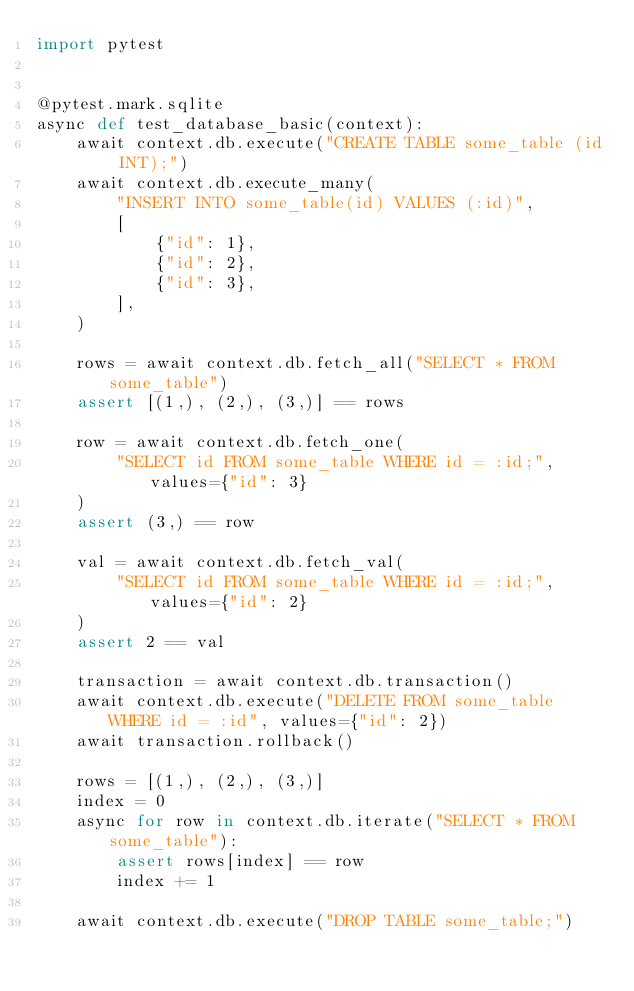<code> <loc_0><loc_0><loc_500><loc_500><_Python_>import pytest


@pytest.mark.sqlite
async def test_database_basic(context):
    await context.db.execute("CREATE TABLE some_table (id INT);")
    await context.db.execute_many(
        "INSERT INTO some_table(id) VALUES (:id)",
        [
            {"id": 1},
            {"id": 2},
            {"id": 3},
        ],
    )

    rows = await context.db.fetch_all("SELECT * FROM some_table")
    assert [(1,), (2,), (3,)] == rows

    row = await context.db.fetch_one(
        "SELECT id FROM some_table WHERE id = :id;", values={"id": 3}
    )
    assert (3,) == row

    val = await context.db.fetch_val(
        "SELECT id FROM some_table WHERE id = :id;", values={"id": 2}
    )
    assert 2 == val

    transaction = await context.db.transaction()
    await context.db.execute("DELETE FROM some_table WHERE id = :id", values={"id": 2})
    await transaction.rollback()

    rows = [(1,), (2,), (3,)]
    index = 0
    async for row in context.db.iterate("SELECT * FROM some_table"):
        assert rows[index] == row
        index += 1

    await context.db.execute("DROP TABLE some_table;")
</code> 